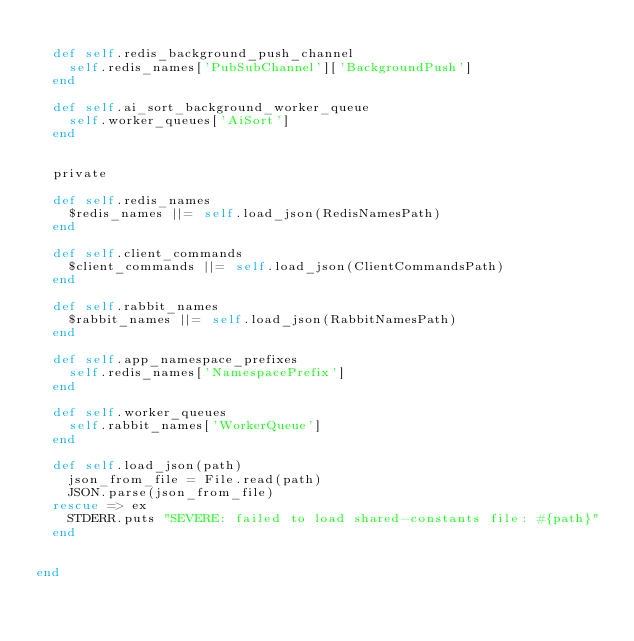Convert code to text. <code><loc_0><loc_0><loc_500><loc_500><_Ruby_>
  def self.redis_background_push_channel
    self.redis_names['PubSubChannel']['BackgroundPush']
  end

  def self.ai_sort_background_worker_queue
    self.worker_queues['AiSort']
  end


  private

  def self.redis_names
    $redis_names ||= self.load_json(RedisNamesPath)
  end

  def self.client_commands
    $client_commands ||= self.load_json(ClientCommandsPath)
  end

  def self.rabbit_names
    $rabbit_names ||= self.load_json(RabbitNamesPath)
  end

  def self.app_namespace_prefixes
    self.redis_names['NamespacePrefix']
  end

  def self.worker_queues
    self.rabbit_names['WorkerQueue']
  end

  def self.load_json(path)
    json_from_file = File.read(path)
    JSON.parse(json_from_file)
  rescue => ex
    STDERR.puts "SEVERE: failed to load shared-constants file: #{path}"
  end


end

</code> 